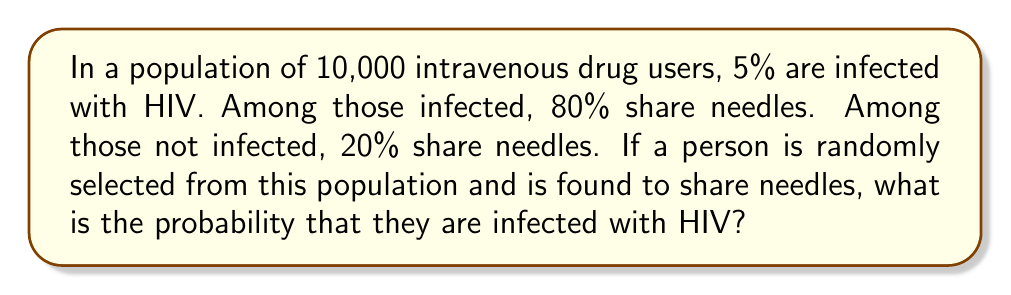Could you help me with this problem? Let's approach this problem using Bayes' Theorem and conditional probability:

1. Define events:
   A: Person is infected with HIV
   B: Person shares needles

2. Given information:
   P(A) = 0.05 (5% are infected)
   P(B|A) = 0.80 (80% of infected share needles)
   P(B|not A) = 0.20 (20% of non-infected share needles)

3. We need to find P(A|B) using Bayes' Theorem:

   $$P(A|B) = \frac{P(B|A) \cdot P(A)}{P(B)}$$

4. Calculate P(B) using the law of total probability:
   $$P(B) = P(B|A) \cdot P(A) + P(B|not A) \cdot P(not A)$$
   $$P(B) = 0.80 \cdot 0.05 + 0.20 \cdot 0.95$$
   $$P(B) = 0.04 + 0.19 = 0.23$$

5. Now apply Bayes' Theorem:
   $$P(A|B) = \frac{0.80 \cdot 0.05}{0.23}$$
   $$P(A|B) = \frac{0.04}{0.23} \approx 0.1739$$

6. Convert to percentage:
   0.1739 * 100% ≈ 17.39%
Answer: The probability that a randomly selected person who shares needles is infected with HIV is approximately 17.39%. 